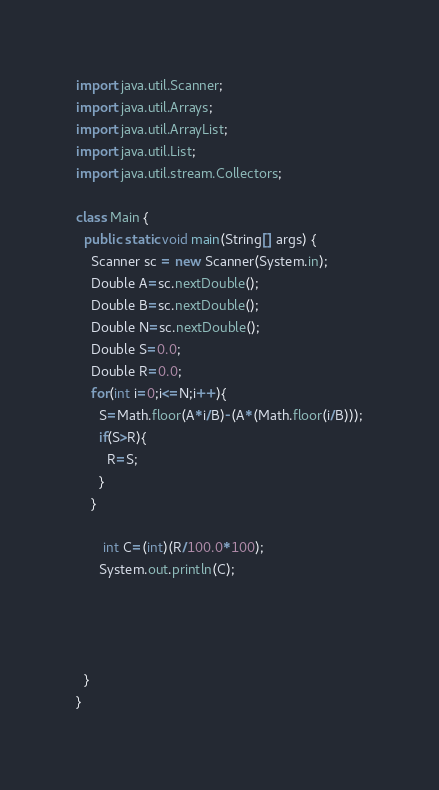<code> <loc_0><loc_0><loc_500><loc_500><_Java_>import java.util.Scanner;
import java.util.Arrays;
import java.util.ArrayList;
import java.util.List;
import java.util.stream.Collectors;

class Main {
  public static void main(String[] args) {
    Scanner sc = new Scanner(System.in);
    Double A=sc.nextDouble();
    Double B=sc.nextDouble();
    Double N=sc.nextDouble();
    Double S=0.0;
    Double R=0.0;
    for(int i=0;i<=N;i++){
      S=Math.floor(A*i/B)-(A*(Math.floor(i/B)));
      if(S>R){
        R=S;
      }
    }

       int C=(int)(R/100.0*100);
      System.out.println(C);




  }
}
</code> 